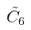Convert formula to latex. <formula><loc_0><loc_0><loc_500><loc_500>\tilde { C } _ { 6 }</formula> 